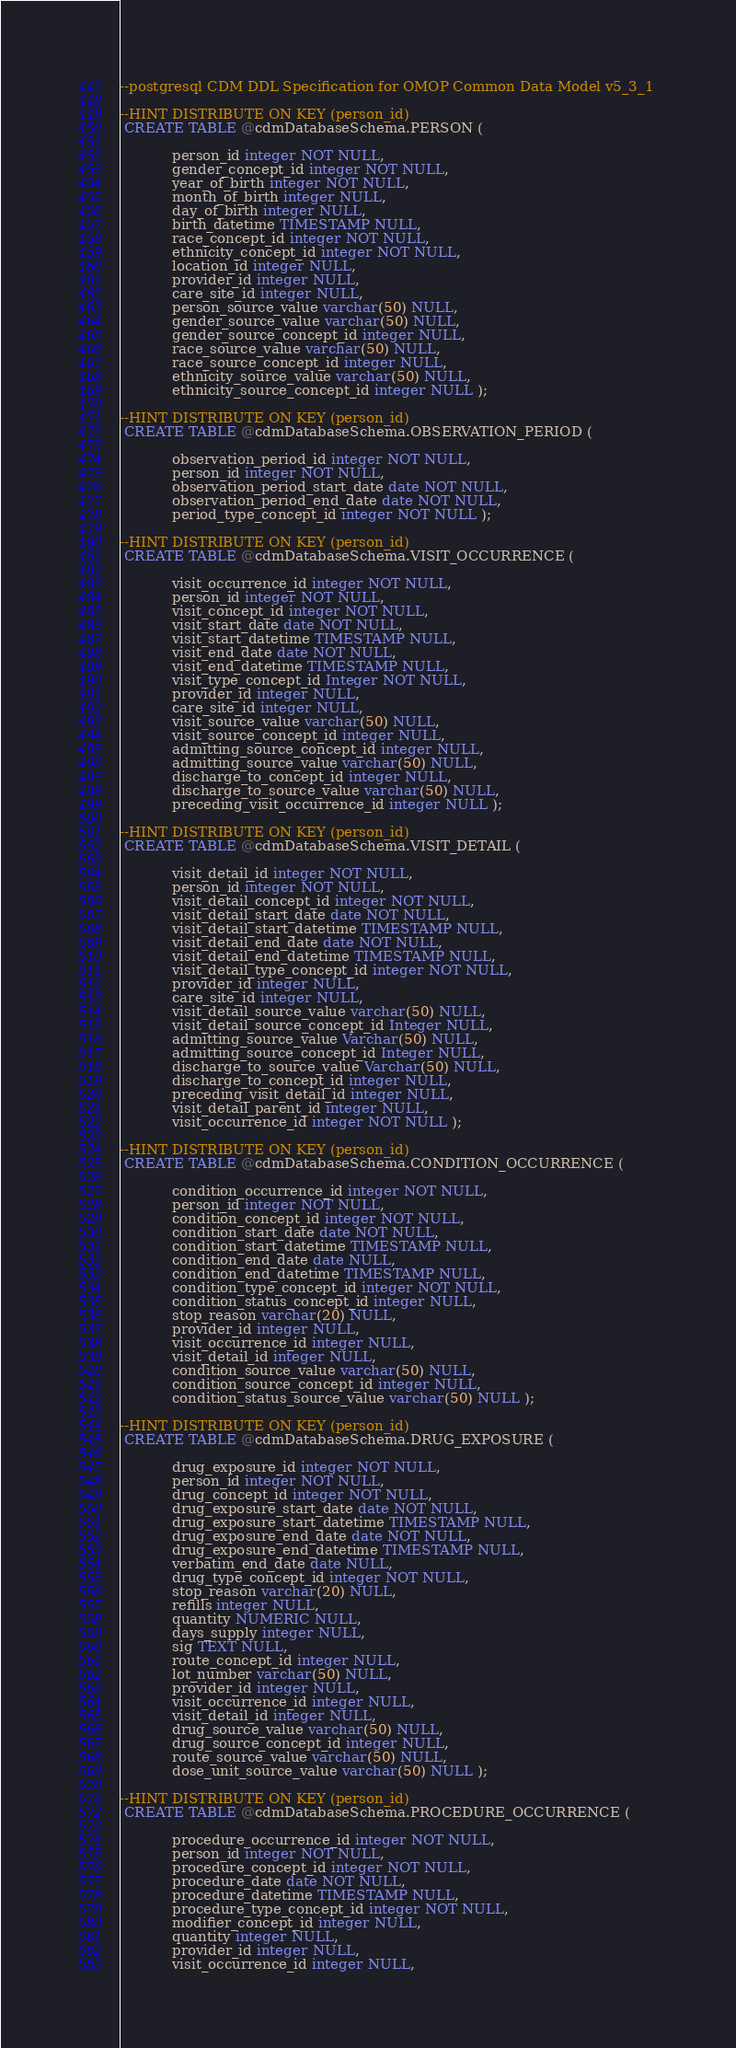Convert code to text. <code><loc_0><loc_0><loc_500><loc_500><_SQL_>--postgresql CDM DDL Specification for OMOP Common Data Model v5_3_1 

--HINT DISTRIBUTE ON KEY (person_id)
 CREATE TABLE @cdmDatabaseSchema.PERSON (
 
			person_id integer NOT NULL, 
			gender_concept_id integer NOT NULL, 
			year_of_birth integer NOT NULL, 
			month_of_birth integer NULL, 
			day_of_birth integer NULL, 
			birth_datetime TIMESTAMP NULL, 
			race_concept_id integer NOT NULL, 
			ethnicity_concept_id integer NOT NULL, 
			location_id integer NULL, 
			provider_id integer NULL, 
			care_site_id integer NULL, 
			person_source_value varchar(50) NULL, 
			gender_source_value varchar(50) NULL, 
			gender_source_concept_id integer NULL, 
			race_source_value varchar(50) NULL, 
			race_source_concept_id integer NULL, 
			ethnicity_source_value varchar(50) NULL, 
			ethnicity_source_concept_id integer NULL );  

--HINT DISTRIBUTE ON KEY (person_id)
 CREATE TABLE @cdmDatabaseSchema.OBSERVATION_PERIOD (
 
			observation_period_id integer NOT NULL, 
			person_id integer NOT NULL, 
			observation_period_start_date date NOT NULL, 
			observation_period_end_date date NOT NULL, 
			period_type_concept_id integer NOT NULL );  

--HINT DISTRIBUTE ON KEY (person_id)
 CREATE TABLE @cdmDatabaseSchema.VISIT_OCCURRENCE (
 
			visit_occurrence_id integer NOT NULL, 
			person_id integer NOT NULL, 
			visit_concept_id integer NOT NULL, 
			visit_start_date date NOT NULL, 
			visit_start_datetime TIMESTAMP NULL, 
			visit_end_date date NOT NULL, 
			visit_end_datetime TIMESTAMP NULL, 
			visit_type_concept_id Integer NOT NULL, 
			provider_id integer NULL, 
			care_site_id integer NULL, 
			visit_source_value varchar(50) NULL, 
			visit_source_concept_id integer NULL, 
			admitting_source_concept_id integer NULL, 
			admitting_source_value varchar(50) NULL, 
			discharge_to_concept_id integer NULL, 
			discharge_to_source_value varchar(50) NULL, 
			preceding_visit_occurrence_id integer NULL );  

--HINT DISTRIBUTE ON KEY (person_id)
 CREATE TABLE @cdmDatabaseSchema.VISIT_DETAIL (
 
			visit_detail_id integer NOT NULL, 
			person_id integer NOT NULL, 
			visit_detail_concept_id integer NOT NULL, 
			visit_detail_start_date date NOT NULL, 
			visit_detail_start_datetime TIMESTAMP NULL, 
			visit_detail_end_date date NOT NULL, 
			visit_detail_end_datetime TIMESTAMP NULL, 
			visit_detail_type_concept_id integer NOT NULL, 
			provider_id integer NULL, 
			care_site_id integer NULL, 
			visit_detail_source_value varchar(50) NULL, 
			visit_detail_source_concept_id Integer NULL, 
			admitting_source_value Varchar(50) NULL, 
			admitting_source_concept_id Integer NULL, 
			discharge_to_source_value Varchar(50) NULL, 
			discharge_to_concept_id integer NULL, 
			preceding_visit_detail_id integer NULL, 
			visit_detail_parent_id integer NULL, 
			visit_occurrence_id integer NOT NULL );  

--HINT DISTRIBUTE ON KEY (person_id)
 CREATE TABLE @cdmDatabaseSchema.CONDITION_OCCURRENCE (
 
			condition_occurrence_id integer NOT NULL, 
			person_id integer NOT NULL, 
			condition_concept_id integer NOT NULL, 
			condition_start_date date NOT NULL, 
			condition_start_datetime TIMESTAMP NULL, 
			condition_end_date date NULL, 
			condition_end_datetime TIMESTAMP NULL, 
			condition_type_concept_id integer NOT NULL, 
			condition_status_concept_id integer NULL, 
			stop_reason varchar(20) NULL, 
			provider_id integer NULL, 
			visit_occurrence_id integer NULL, 
			visit_detail_id integer NULL, 
			condition_source_value varchar(50) NULL, 
			condition_source_concept_id integer NULL, 
			condition_status_source_value varchar(50) NULL );  

--HINT DISTRIBUTE ON KEY (person_id)
 CREATE TABLE @cdmDatabaseSchema.DRUG_EXPOSURE (
 
			drug_exposure_id integer NOT NULL, 
			person_id integer NOT NULL, 
			drug_concept_id integer NOT NULL, 
			drug_exposure_start_date date NOT NULL, 
			drug_exposure_start_datetime TIMESTAMP NULL, 
			drug_exposure_end_date date NOT NULL, 
			drug_exposure_end_datetime TIMESTAMP NULL, 
			verbatim_end_date date NULL, 
			drug_type_concept_id integer NOT NULL, 
			stop_reason varchar(20) NULL, 
			refills integer NULL, 
			quantity NUMERIC NULL, 
			days_supply integer NULL, 
			sig TEXT NULL, 
			route_concept_id integer NULL, 
			lot_number varchar(50) NULL, 
			provider_id integer NULL, 
			visit_occurrence_id integer NULL, 
			visit_detail_id integer NULL, 
			drug_source_value varchar(50) NULL, 
			drug_source_concept_id integer NULL, 
			route_source_value varchar(50) NULL, 
			dose_unit_source_value varchar(50) NULL );  

--HINT DISTRIBUTE ON KEY (person_id)
 CREATE TABLE @cdmDatabaseSchema.PROCEDURE_OCCURRENCE (
 
			procedure_occurrence_id integer NOT NULL, 
			person_id integer NOT NULL, 
			procedure_concept_id integer NOT NULL, 
			procedure_date date NOT NULL, 
			procedure_datetime TIMESTAMP NULL, 
			procedure_type_concept_id integer NOT NULL, 
			modifier_concept_id integer NULL, 
			quantity integer NULL, 
			provider_id integer NULL, 
			visit_occurrence_id integer NULL, </code> 